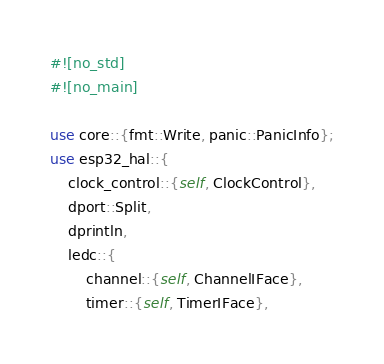Convert code to text. <code><loc_0><loc_0><loc_500><loc_500><_Rust_>#![no_std]
#![no_main]

use core::{fmt::Write, panic::PanicInfo};
use esp32_hal::{
    clock_control::{self, ClockControl},
    dport::Split,
    dprintln,
    ledc::{
        channel::{self, ChannelIFace},
        timer::{self, TimerIFace},</code> 